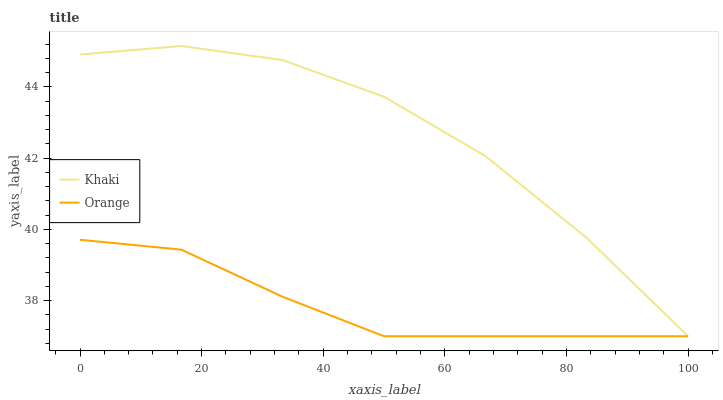Does Orange have the minimum area under the curve?
Answer yes or no. Yes. Does Khaki have the maximum area under the curve?
Answer yes or no. Yes. Does Khaki have the minimum area under the curve?
Answer yes or no. No. Is Orange the smoothest?
Answer yes or no. Yes. Is Khaki the roughest?
Answer yes or no. Yes. Is Khaki the smoothest?
Answer yes or no. No. Does Orange have the lowest value?
Answer yes or no. Yes. Does Khaki have the highest value?
Answer yes or no. Yes. Does Khaki intersect Orange?
Answer yes or no. Yes. Is Khaki less than Orange?
Answer yes or no. No. Is Khaki greater than Orange?
Answer yes or no. No. 